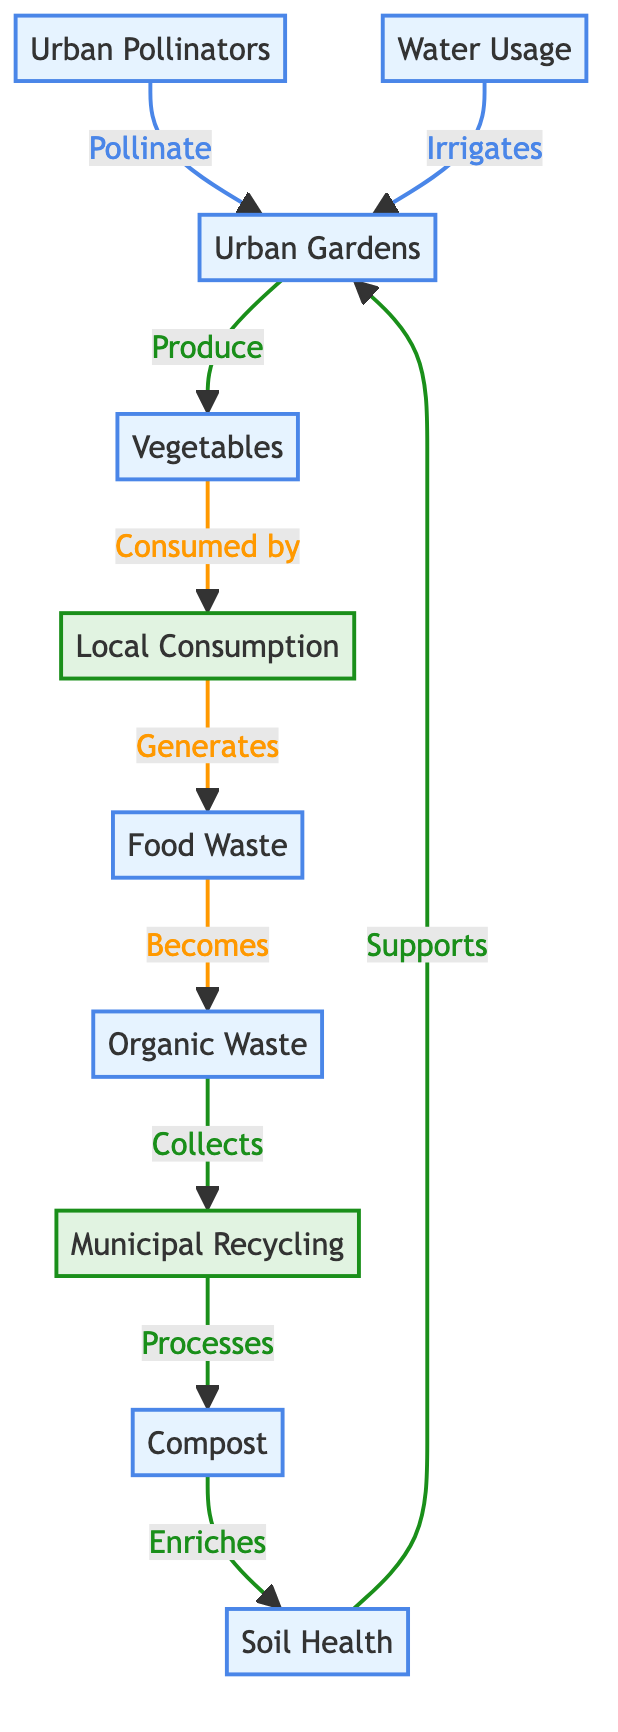What is the primary resource produced by urban gardens? According to the diagram, urban gardens produce vegetables, which are directly linked to the "Produce" action from urban gardens to the vegetables node.
Answer: Vegetables How many main resources are shown in the diagram? The diagram identifies six main resources: Urban Gardens, Organic Waste, Compost, Soil Health, Vegetables, and Urban Pollinators. By counting these nodes representing resources, we find a total of six.
Answer: Six What role does compost play in the food chain dynamics? Compost is shown to enrich soil health in the diagram. The flow from compost to soil health indicates its function in improving the quality of the soil, which supports urban gardens for further vegetable production.
Answer: Enriches How does local consumption affect food waste in this ecosystem? Local consumption generates food waste, as depicted in the flow from local consumption leading to food waste in the diagram. This indicates a direct relationship where consumption leads to waste generation.
Answer: Generates What is required for urban gardens to be irrigated? The diagram indicates that water usage is required for irrigating urban gardens. There is a direct flow showing the necessity of water usage for the irrigation process.
Answer: Water Usage How does organic waste become part of the food chain again? Organic waste is collected through municipal recycling, which then processes into compost. This compost enriches soil health, supporting urban gardens that produce vegetables, thus recycling the organic waste back into the food chain.
Answer: Becomes Compost What enhances the productivity of urban gardens based on the diagram? Both soil health and urban pollinators enhance the productivity of urban gardens. The arrows in the diagram indicate that soil health supports urban gardens and urban pollinators provide pollination, both contributing to greater garden productivity.
Answer: Soil Health and Urban Pollinators How many processes are identified between resources in this food chain diagram? The diagram identifies three processes: municipal recycling, local consumption, and food waste. By recognizing and counting the processes depicted as actions in the flow, we establish there are three distinct processes.
Answer: Three 